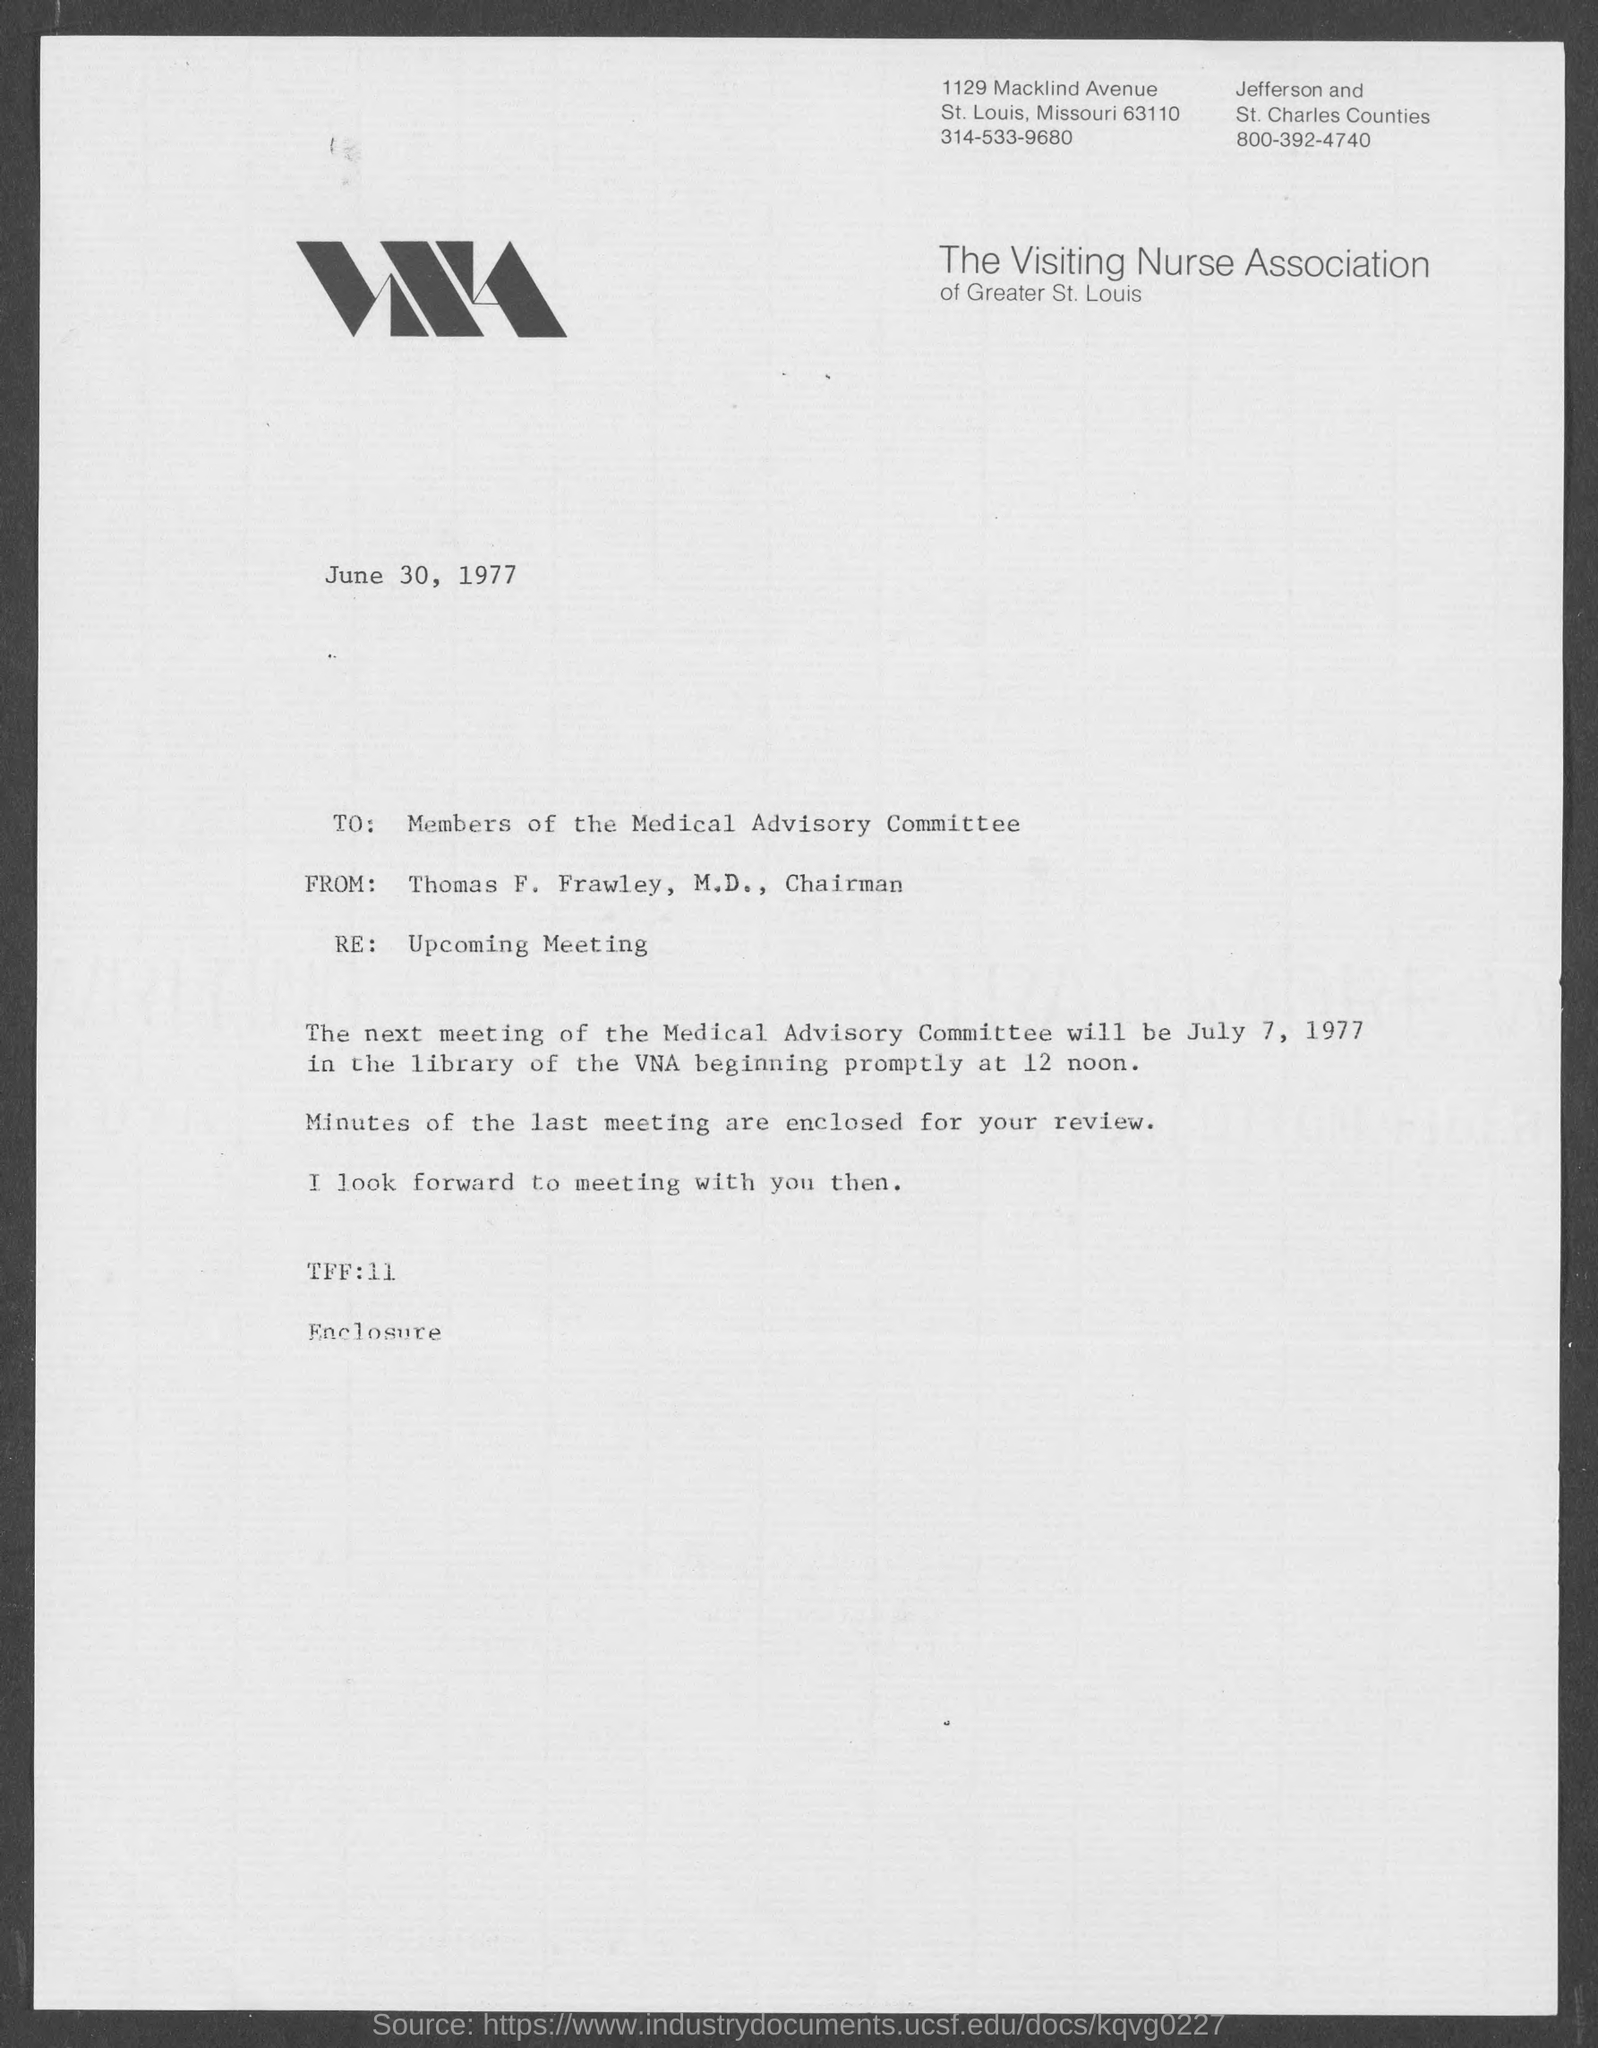What is the contact number of the visiting nurse association of greater st. louis, st. louis county  ?
Your response must be concise. 314-533-9680. When is the memorandum dated?
Ensure brevity in your answer.  June 30, 1977. What is the subject of memorandum ?
Offer a terse response. Upcoming Meeting. What is the from address in memorandum ?
Ensure brevity in your answer.  Thomas F. Frawley, M.D., Chairman. What is the position of thomas f. frawley, m.d.,?
Provide a short and direct response. Chairman. 